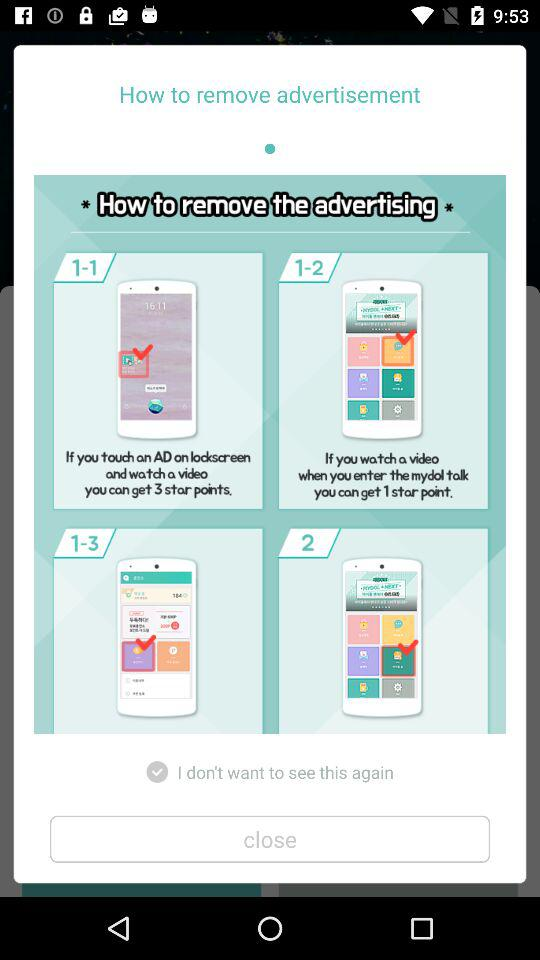What is the status of "I don't want to see this again"? The status of "I don't want to see this again" is "on". 